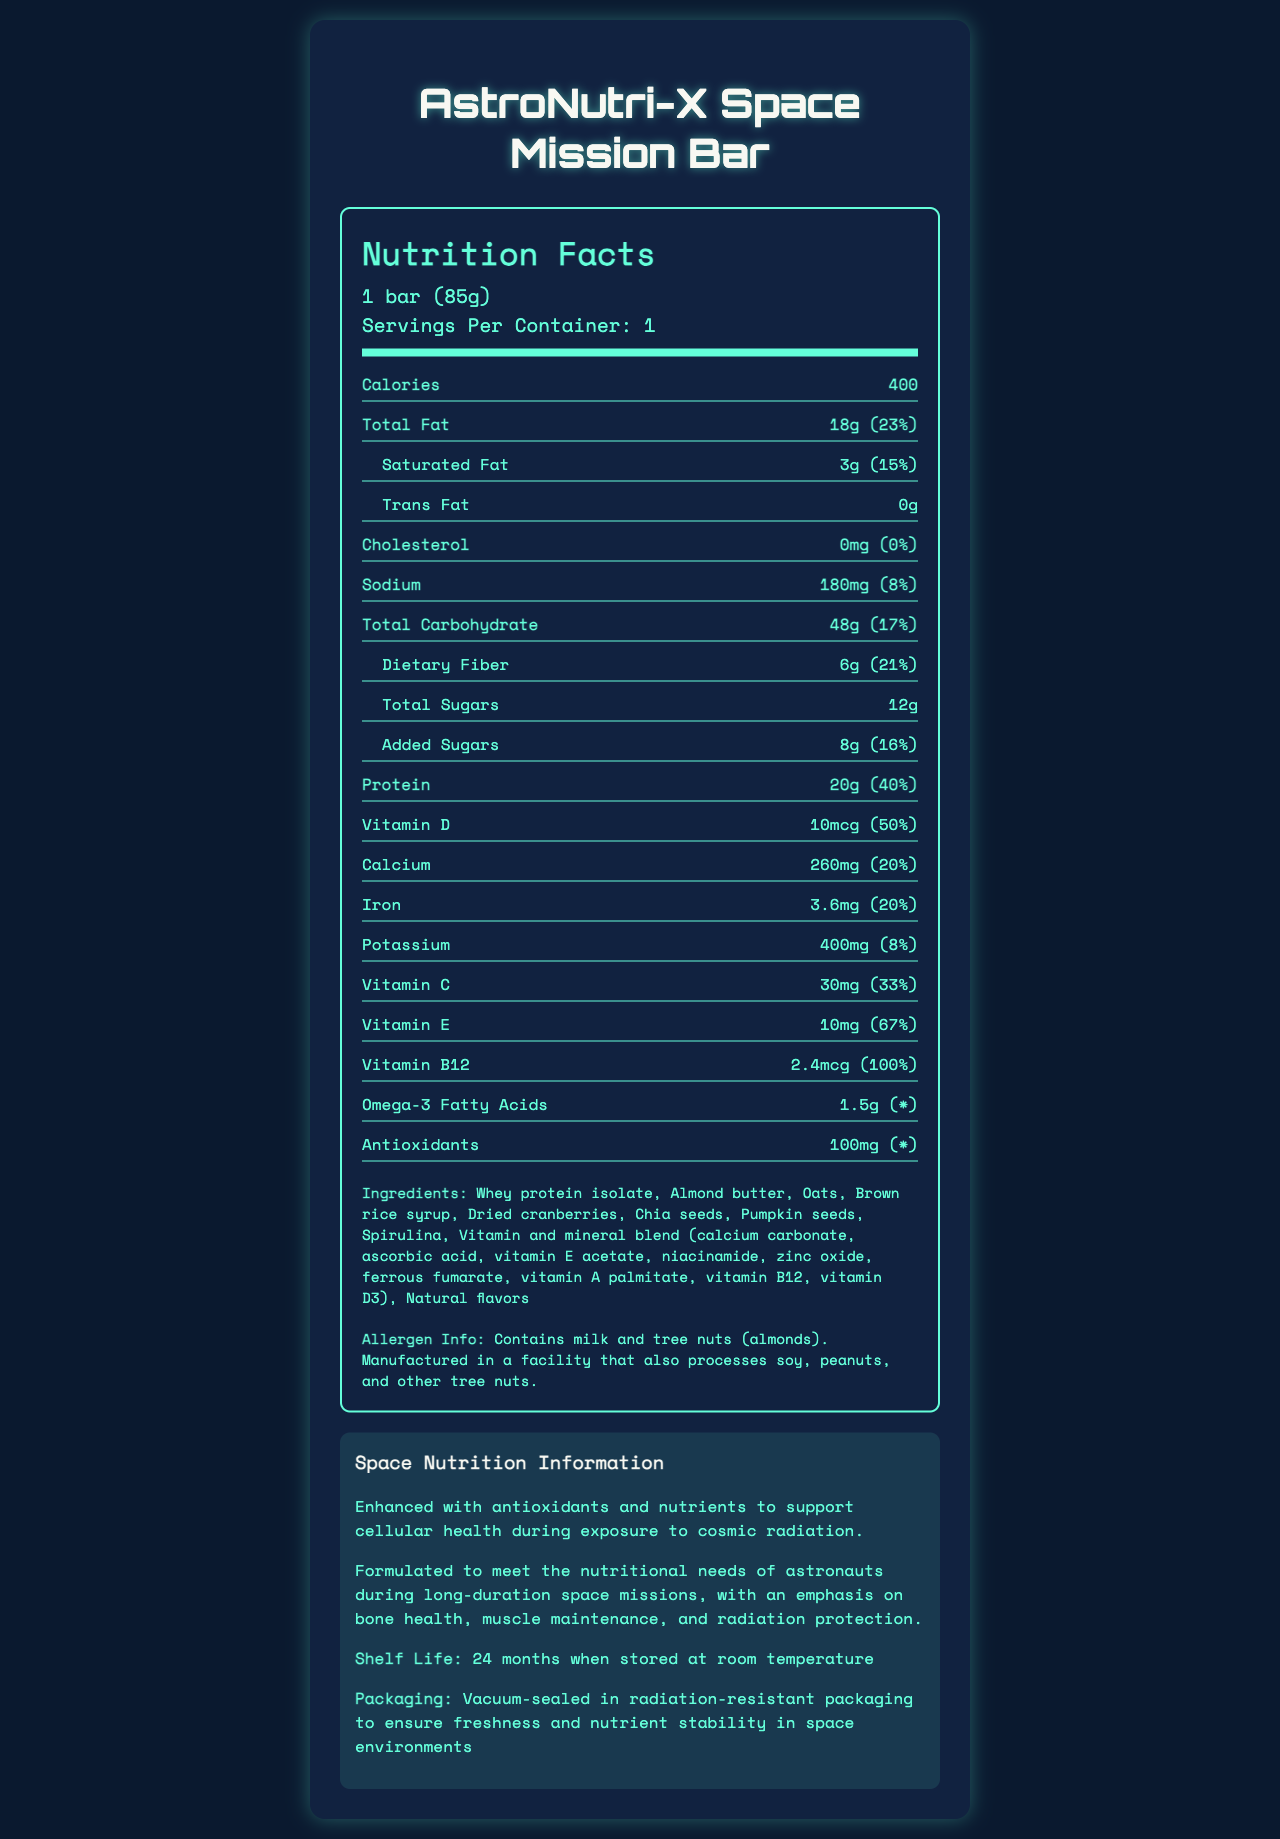what is the serving size of AstroNutri-X Space Mission Bar? The serving size is clearly indicated at the beginning of the nutrition facts section.
Answer: 1 bar (85g) how many calories are in one serving of AstroNutri-X Space Mission Bar? The calories per serving are specified in the nutrition facts section as 400.
Answer: 400 what is the shelf life of the AstroNutri-X Space Mission Bar? The shelf life information is mentioned in the space nutrition information section.
Answer: 24 months when stored at room temperature what are the ingredients of the AstroNutri-X Space Mission Bar? The ingredients are listed towards the end of the document under the ingredients section.
Answer: Whey protein isolate, Almond butter, Oats, Brown rice syrup, Dried cranberries, Chia seeds, Pumpkin seeds, Spirulina, Vitamin and mineral blend (calcium carbonate, ascorbic acid, vitamin E acetate, niacinamide, zinc oxide, ferrous fumarate, vitamin A palmitate, vitamin B12, vitamin D3), Natural flavors what is the amount of protein per serving, and how does it contribute to the daily value? The amount of protein per serving is listed as 20g, which contributes to 40% of the daily value, according to the nutrition facts section.
Answer: 20g, 40% how does the product support cellular health during exposure to cosmic radiation? The document claims that it is "Enhanced with antioxidants and nutrients to support cellular health during exposure to cosmic radiation" in the space nutrition information section.
Answer: Enhanced with antioxidants and nutrients which of the following vitamins has the highest daily value percentage in the AstroNutri-X Space Mission Bar? A. Vitamin D B. Vitamin C C. Vitamin E D. Vitamin B12 Vitamin B12 has a daily value percentage of 100%, which is higher than Vitamin D (50%), Vitamin C (33%), and Vitamin E (67%).
Answer: D. Vitamin B12 how much calcium is present in the bar, and what percentage of the daily value does it provide? A. 200mg, 15% B. 260mg, 20% C. 300mg, 25% D. 350mg, 30% The nutrition facts section details that there are 260mg of calcium present, which provides 20% of the daily value.
Answer: B. 260mg, 20% is the product allergen-free? The allergen information section mentions that the product contains milk and tree nuts (almonds) and is manufactured in a facility that also processes soy, peanuts, and other tree nuts.
Answer: No what is the emphasis of the product’s formulation according to the space nutrition note? The space nutrition note states that the product is formulated with an emphasis on bone health, muscle maintenance, and radiation protection.
Answer: Bone health, muscle maintenance, and radiation protection summarize the overall information provided in this document. The explanation encompasses the key nutritional facts, allergen information, space-specific notes, and the purpose of the product.
Answer: The AstroNutri-X Space Mission Bar is a nutrient-dense energy bar designed for long-duration space missions. Each bar is 85g and provides 400 calories. It includes significant amounts of protein, various vitamins, and minerals, while also being enhanced with antioxidants and omega-3 fatty acids. The bar aims to support bone health, muscle maintenance, and cellular health during exposure to cosmic radiation. It has a shelf life of 24 months and is packged in radiation-resistant materials. The ingredients include almond butter, whey protein isolate, and a blend of vitamins and minerals. The product contains allergens such as milk and tree nuts and is produced in a facility that also processes other nuts and soy. how much of the daily value of omega-3 fatty acids does the bar provide? The document lists the amount of omega-3 fatty acids (1.5g) but does not provide the daily value percentage, as indicated by the asterisk (*) in the nutrition facts section.
Answer: Cannot be determined how many grams of total carbohydrates are there per serving? The amount of total carbohydrate per serving is clearly stated as 48g in the nutrition facts section.
Answer: 48g 